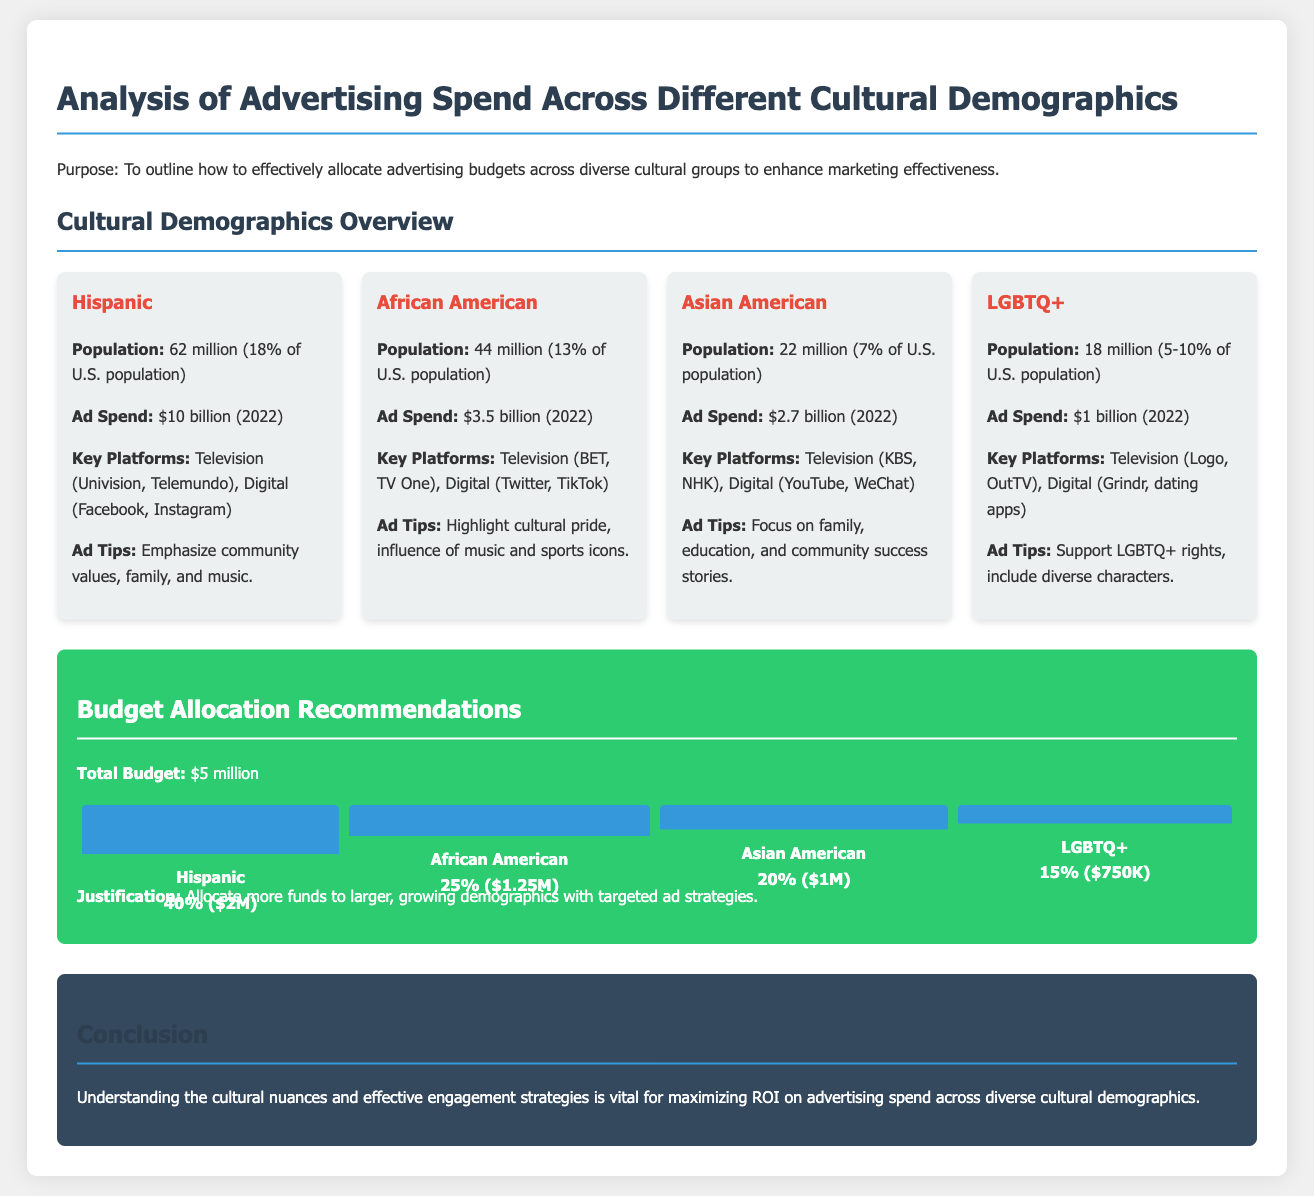What is the population of the Hispanic demographic? The population of the Hispanic demographic is mentioned as 62 million.
Answer: 62 million What is the advertising spend for the African American demographic? The advertising spend for the African American demographic is listed as $3.5 billion.
Answer: $3.5 billion Which platform is key for the Asian American demographic? The key platforms for Asian American advertising are listed in the document, with YouTube and WeChat mentioned.
Answer: YouTube, WeChat What percentage of the total budget is allocated to the LGBTQ+ demographic? The document states that 15% of the total budget is allocated to the LGBTQ+ demographic.
Answer: 15% What is the total budget mentioned in the document? The total budget for advertising spend is stated as $5 million.
Answer: $5 million Which cultural demographic has the highest ad spend? The document provides information about ad spends, with the Hispanic demographic noted as the highest at $10 billion.
Answer: Hispanic What is a key ad tip for the African American demographic? The document includes ad tips, indicating that highlighting cultural pride is important for the African American demographic.
Answer: Highlight cultural pride What is the budget allocation for the Asian American demographic? The document specifies that the budget allocation for the Asian American demographic is $1 million.
Answer: $1 million What is the purpose of the documented analysis? The document outlines the purpose as enhancing marketing effectiveness through budget allocation across cultural groups.
Answer: Enhance marketing effectiveness 